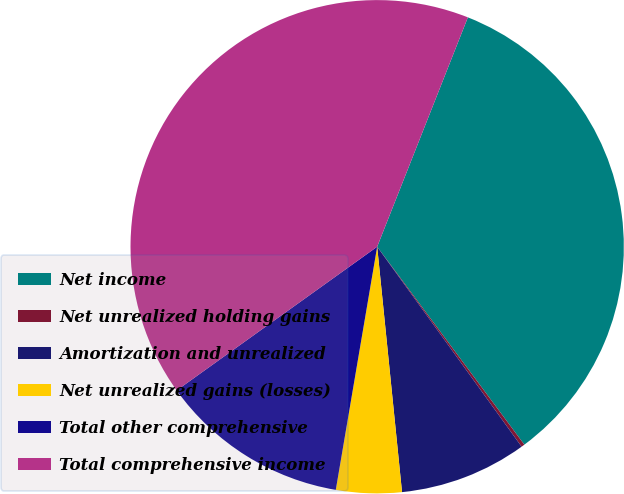<chart> <loc_0><loc_0><loc_500><loc_500><pie_chart><fcel>Net income<fcel>Net unrealized holding gains<fcel>Amortization and unrealized<fcel>Net unrealized gains (losses)<fcel>Total other comprehensive<fcel>Total comprehensive income<nl><fcel>33.83%<fcel>0.22%<fcel>8.35%<fcel>4.29%<fcel>12.42%<fcel>40.89%<nl></chart> 